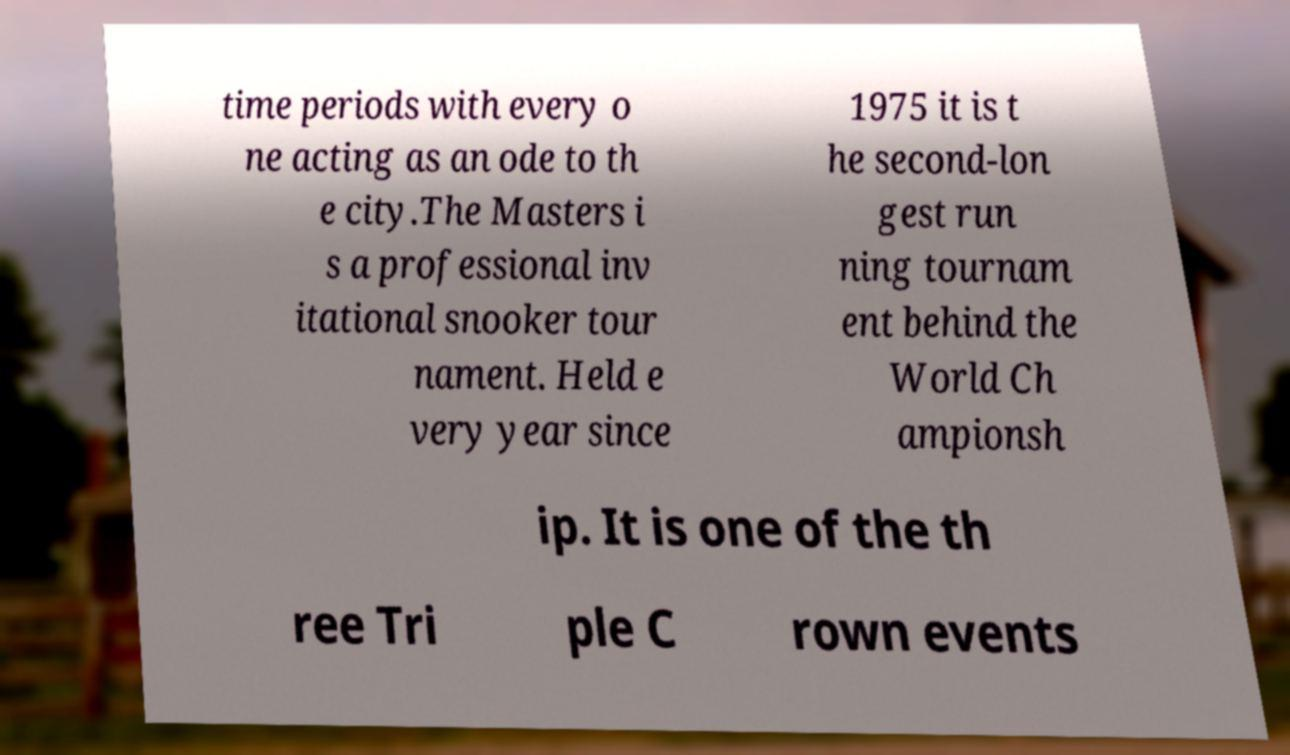There's text embedded in this image that I need extracted. Can you transcribe it verbatim? time periods with every o ne acting as an ode to th e city.The Masters i s a professional inv itational snooker tour nament. Held e very year since 1975 it is t he second-lon gest run ning tournam ent behind the World Ch ampionsh ip. It is one of the th ree Tri ple C rown events 